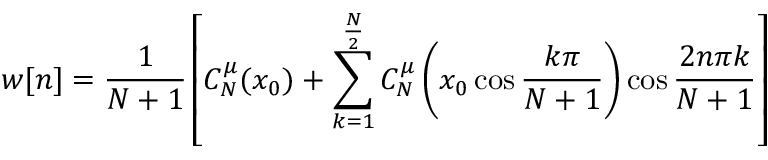<formula> <loc_0><loc_0><loc_500><loc_500>w [ n ] = { \frac { 1 } { N + 1 } } \left [ C _ { N } ^ { \mu } ( x _ { 0 } ) + \sum _ { k = 1 } ^ { \frac { N } { 2 } } C _ { N } ^ { \mu } \left ( x _ { 0 } \cos { \frac { k \pi } { N + 1 } } \right ) \cos { \frac { 2 n \pi k } { N + 1 } } \right ]</formula> 